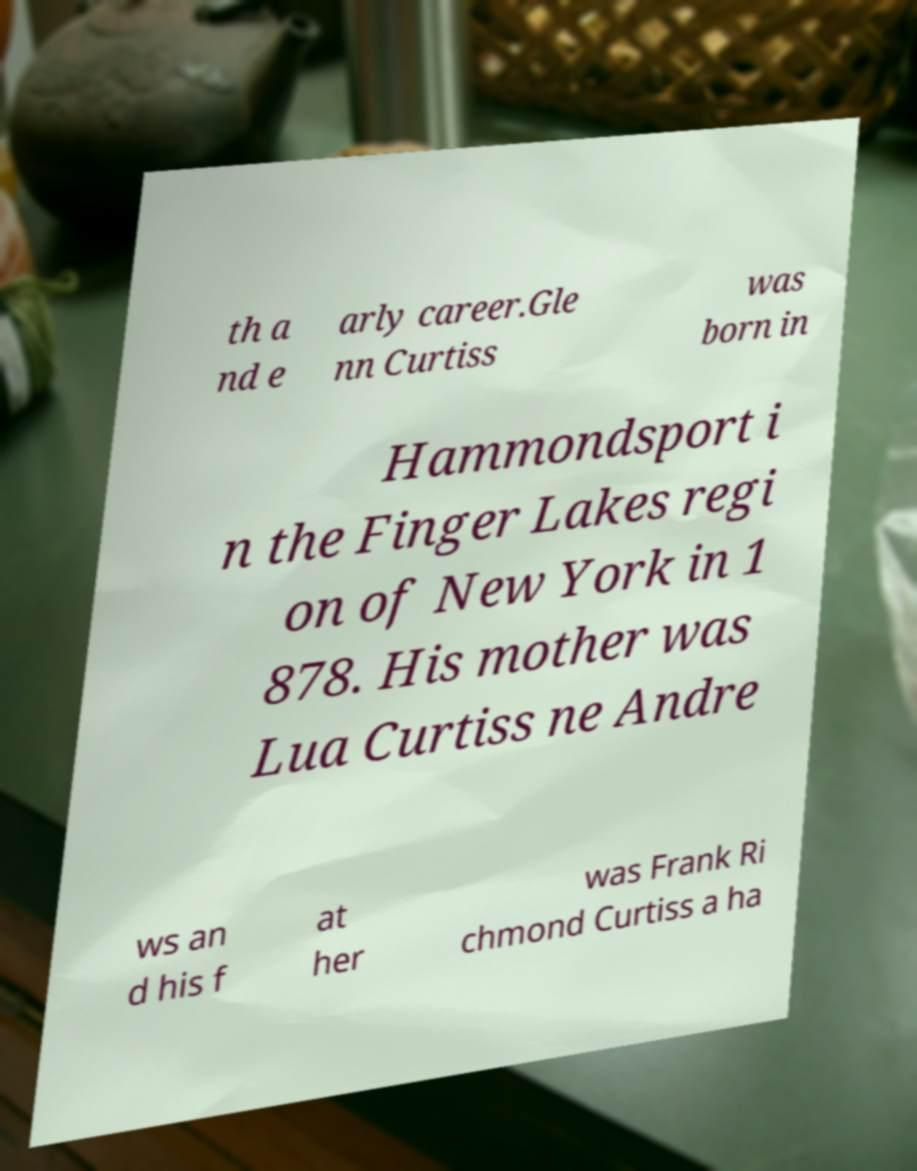There's text embedded in this image that I need extracted. Can you transcribe it verbatim? th a nd e arly career.Gle nn Curtiss was born in Hammondsport i n the Finger Lakes regi on of New York in 1 878. His mother was Lua Curtiss ne Andre ws an d his f at her was Frank Ri chmond Curtiss a ha 